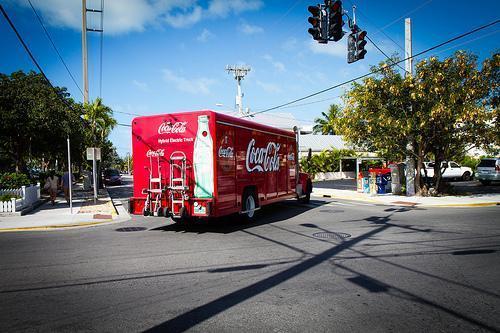How many trucks are in the street?
Give a very brief answer. 1. How many vehicles are shown?
Give a very brief answer. 5. How many handcarts are shown?
Give a very brief answer. 2. 